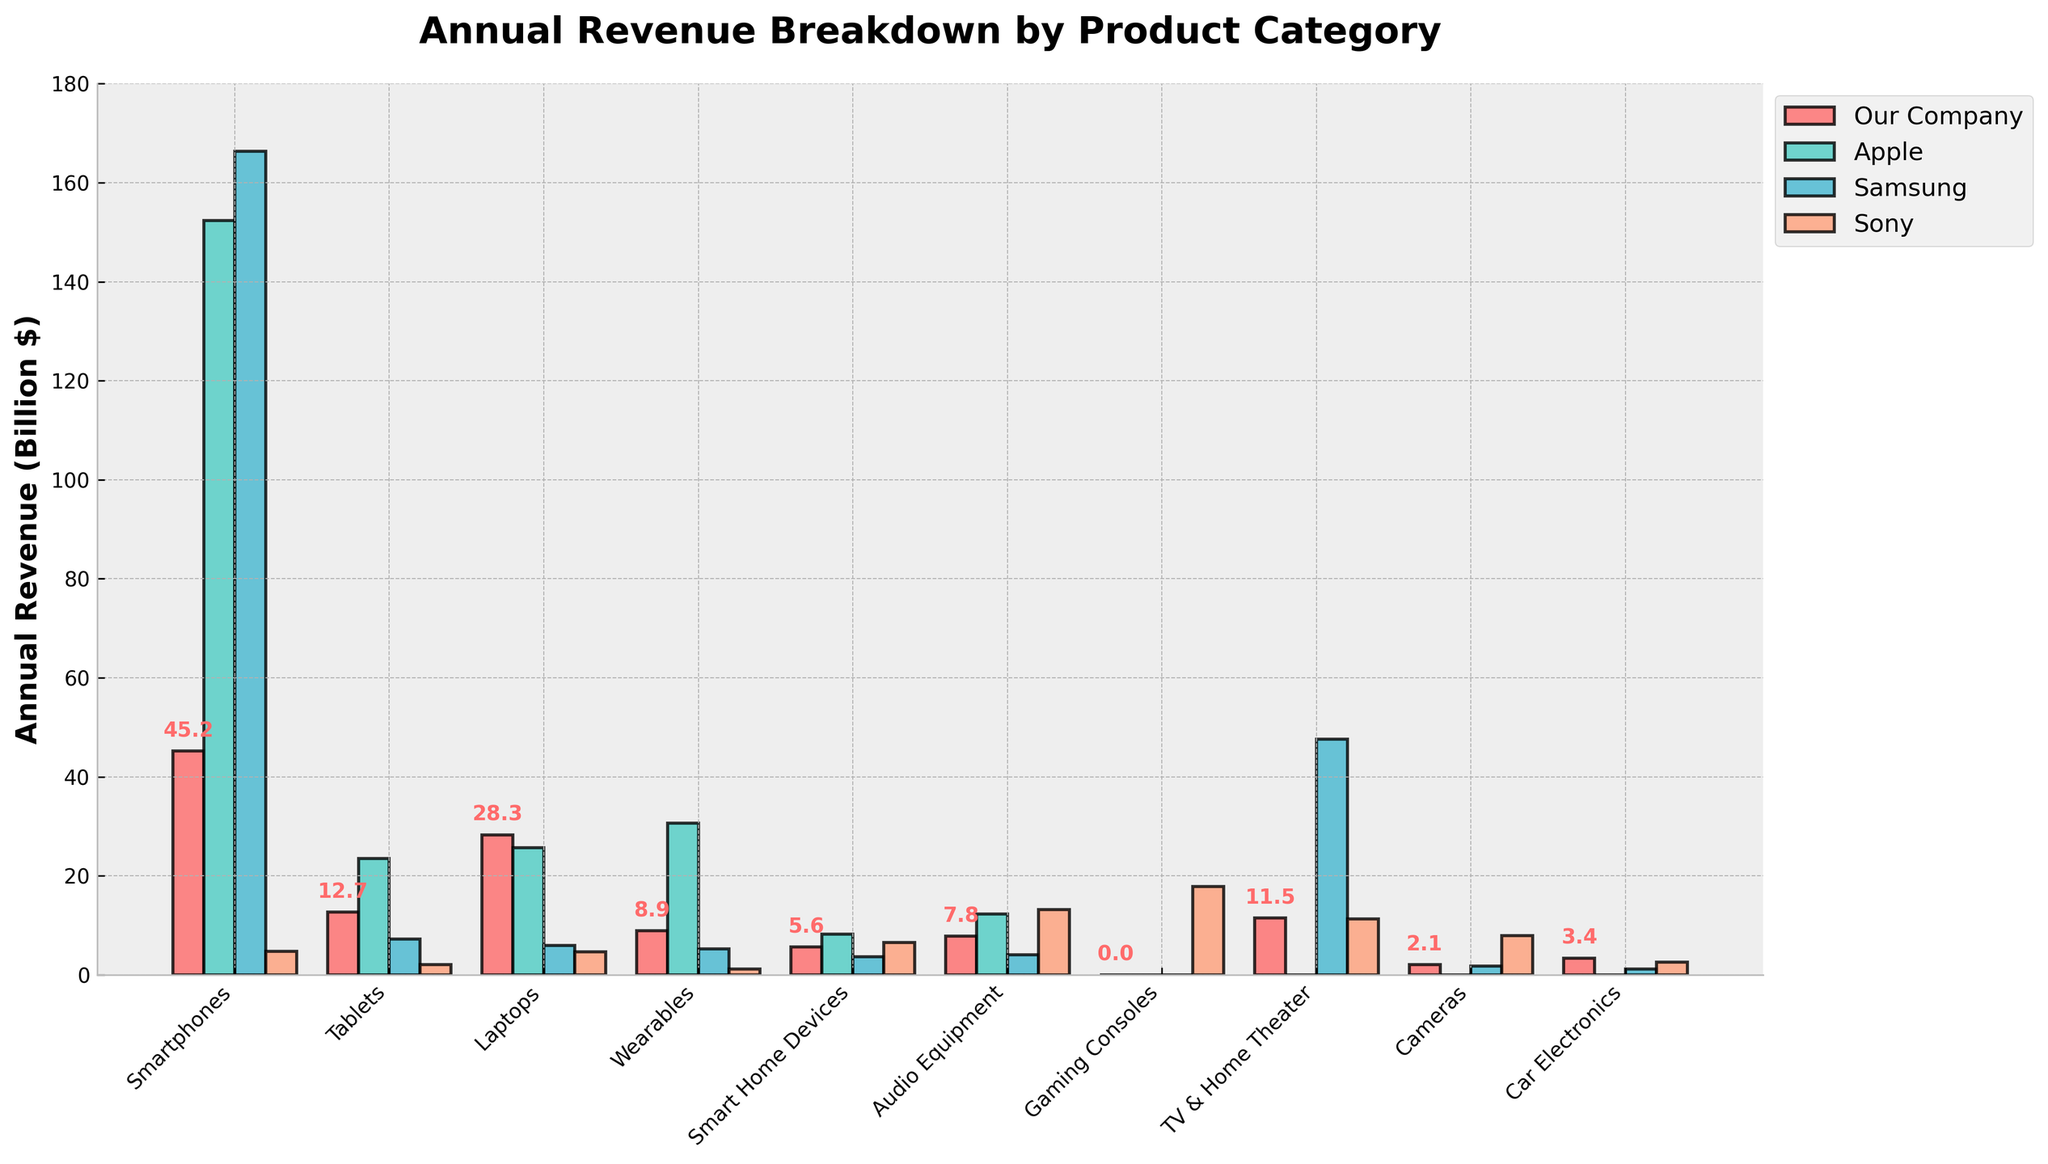Which product category generates the highest revenue for our company? By examining the bar heights for "Our Company", the highest bar corresponds to "Smartphones".
Answer: Smartphones Among "Tablets", which company generates the highest revenue? Looking at the bar heights for the "Tablets" category, the tallest bar belongs to Apple.
Answer: Apple What's the total combined revenue for our company from "Smartphones" and "Laptops"? Our company's revenue from Smartphones is 45.2 and from Laptops is 28.3. Adding these together gives 45.2 + 28.3 = 73.5.
Answer: 73.5 Which product category shows the most significant competition from Samsung compared to our company's revenue? By comparing our company and Samsung's bar heights, the largest difference is observed in the "TV & Home Theater" category, where Samsung's bar is significantly higher.
Answer: TV & Home Theater How does our company's revenue from "Audio Equipment" compare visually to Sony's revenue in the same category? The bar representing our company's revenue in "Audio Equipment" is shorter than Sony's. Hence, Sony generates more revenue in this category.
Answer: Sony generates more revenue Which product category has the closest revenue figures between our company and Apple? The revenue figures for "Laptops" show that our company's bar and Apple's bar are quite close in height.
Answer: Laptops What's the difference in revenue for "Wearables" between our company and Samsung? Our company's revenue for Wearables is 8.9, and Samsung's is 5.3. The difference is 8.9 - 5.3 = 3.6.
Answer: 3.6 How does our company's revenue from "Smart Home Devices" compare visually to Apple's revenue in the same category? The bar representing our company's revenue in "Smart Home Devices" is visually shorter than Apple's bar.
Answer: Shorter than Apple In which category does Sony generate markedly higher revenue than our company? In the "Gaming Consoles" category, Sony has a significant revenue of 17.8, while our company has 0.
Answer: Gaming Consoles What's the combined revenue from "Wearables" and "Audio Equipment" for our company? Our company's revenue from Wearables is 8.9 and from Audio Equipment is 7.8. Adding these together gives 8.9 + 7.8 = 16.7.
Answer: 16.7 